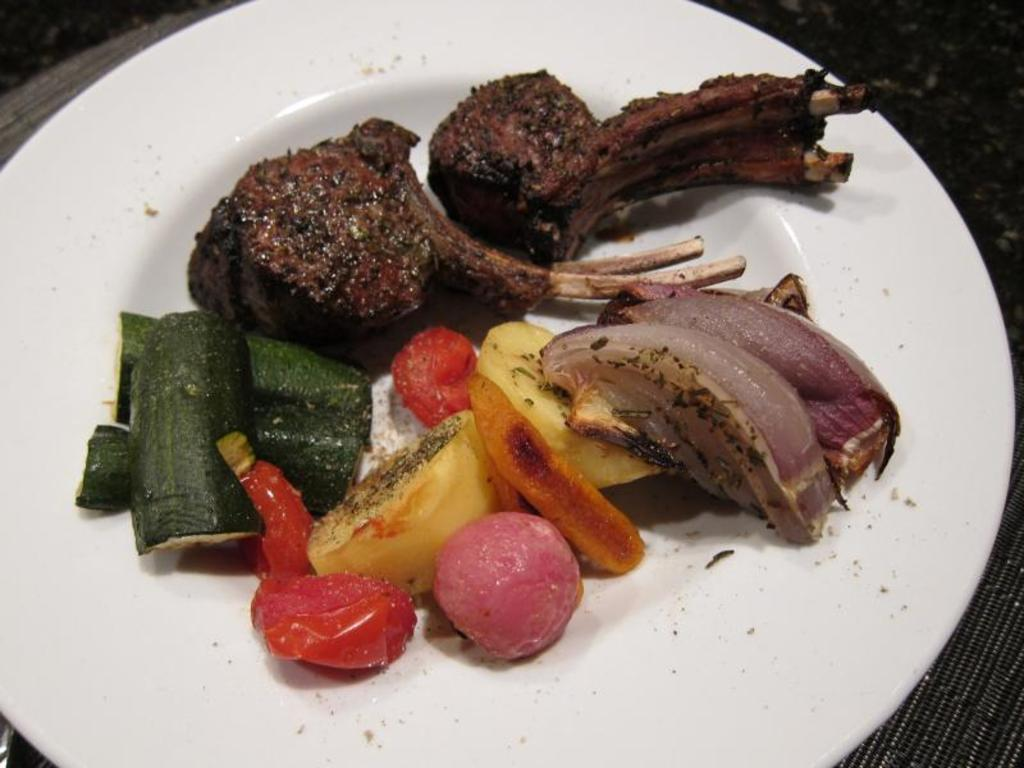What is on the plate that is visible in the image? There is a plate of food items in the image. Where is the plate located in the image? The plate is placed on a surface in the image. What type of bucket is used to cook the food items in the image? There is no bucket or cooking activity present in the image; it only shows a plate of food items. Can you see a goose in the image? There is no goose present in the image. 